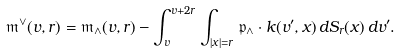Convert formula to latex. <formula><loc_0><loc_0><loc_500><loc_500>\mathfrak { m } ^ { \vee } ( v , r ) = \mathfrak { m } _ { \wedge } ( v , r ) - \int _ { v } ^ { v + 2 r } \int _ { | x | = r } \mathfrak { p } _ { \wedge } \cdot k ( v ^ { \prime } , x ) \, d S _ { r } ( x ) \, d v ^ { \prime } .</formula> 